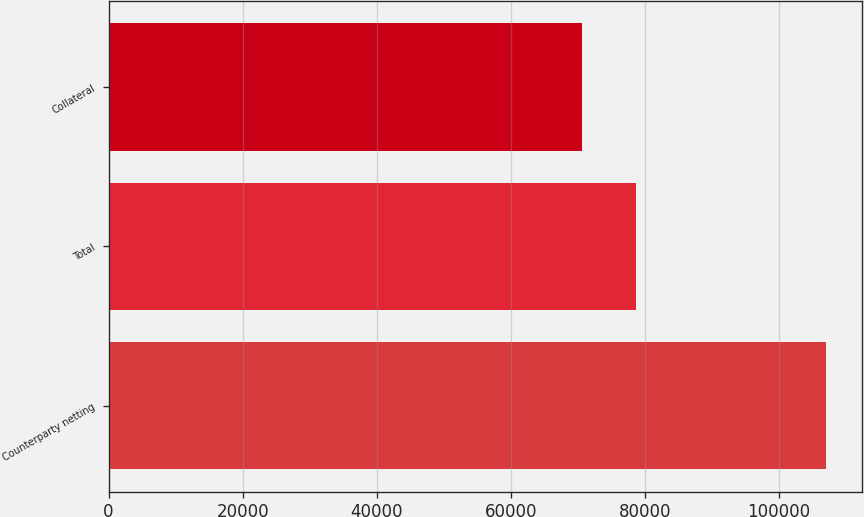Convert chart to OTSL. <chart><loc_0><loc_0><loc_500><loc_500><bar_chart><fcel>Counterparty netting<fcel>Total<fcel>Collateral<nl><fcel>107026<fcel>78723<fcel>70691<nl></chart> 